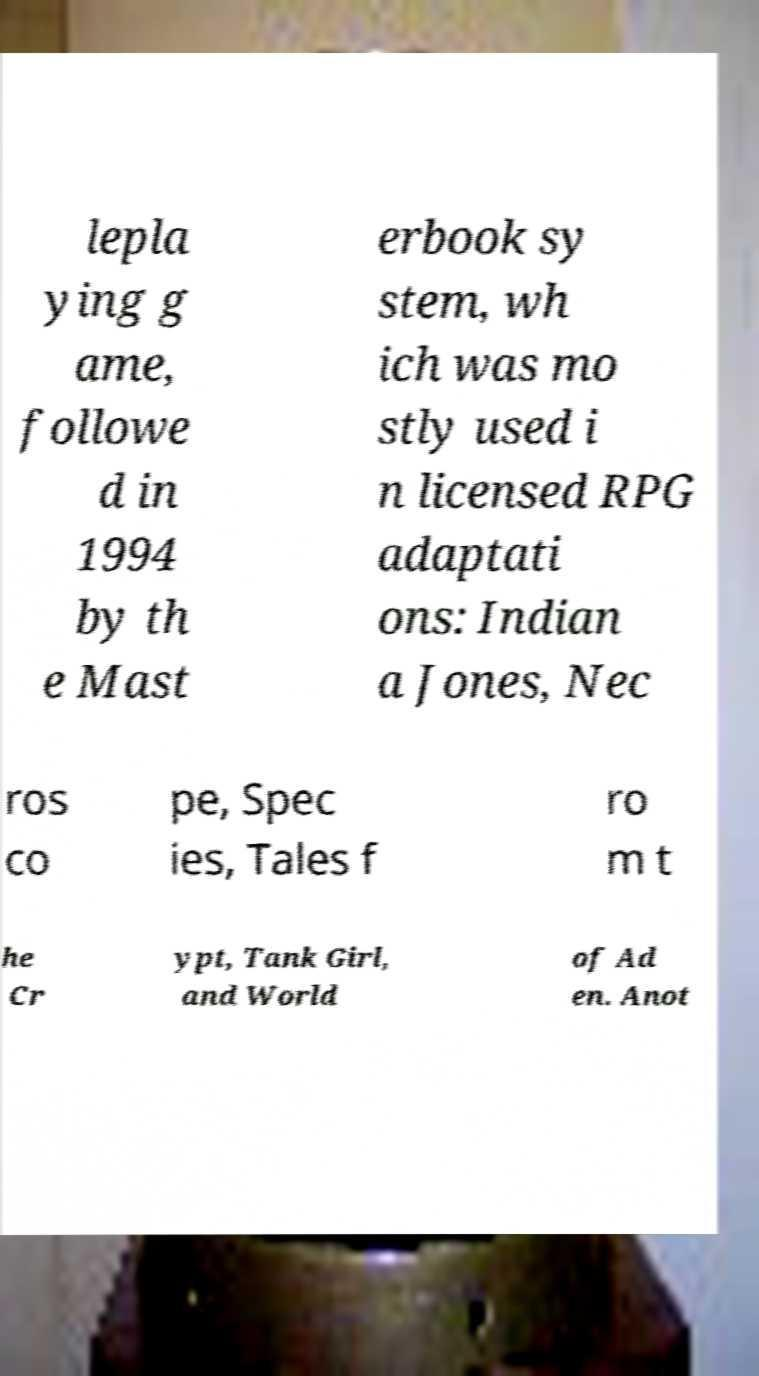Please identify and transcribe the text found in this image. lepla ying g ame, followe d in 1994 by th e Mast erbook sy stem, wh ich was mo stly used i n licensed RPG adaptati ons: Indian a Jones, Nec ros co pe, Spec ies, Tales f ro m t he Cr ypt, Tank Girl, and World of Ad en. Anot 